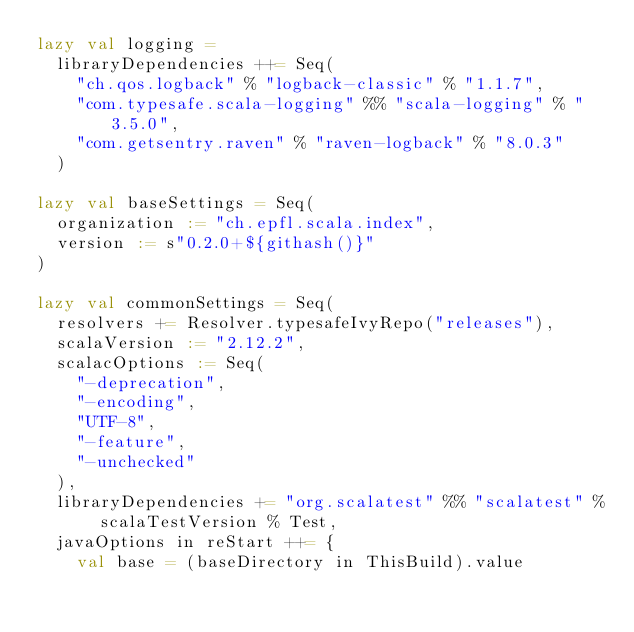<code> <loc_0><loc_0><loc_500><loc_500><_Scala_>lazy val logging =
  libraryDependencies ++= Seq(
    "ch.qos.logback" % "logback-classic" % "1.1.7",
    "com.typesafe.scala-logging" %% "scala-logging" % "3.5.0",
    "com.getsentry.raven" % "raven-logback" % "8.0.3"
  )

lazy val baseSettings = Seq(
  organization := "ch.epfl.scala.index",
  version := s"0.2.0+${githash()}"
)

lazy val commonSettings = Seq(
  resolvers += Resolver.typesafeIvyRepo("releases"),
  scalaVersion := "2.12.2",
  scalacOptions := Seq(
    "-deprecation",
    "-encoding",
    "UTF-8",
    "-feature",
    "-unchecked"
  ),
  libraryDependencies += "org.scalatest" %% "scalatest" % scalaTestVersion % Test,
  javaOptions in reStart ++= {
    val base = (baseDirectory in ThisBuild).value
</code> 